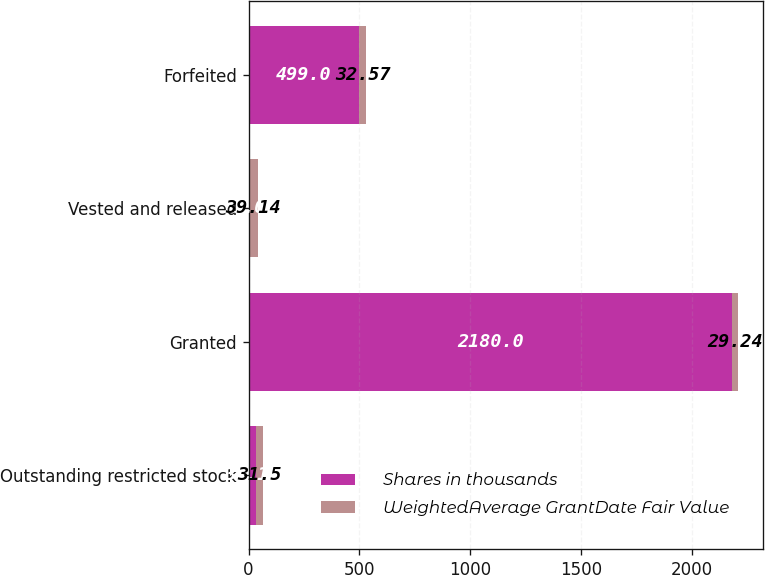Convert chart to OTSL. <chart><loc_0><loc_0><loc_500><loc_500><stacked_bar_chart><ecel><fcel>Outstanding restricted stock<fcel>Granted<fcel>Vested and released<fcel>Forfeited<nl><fcel>Shares in thousands<fcel>33.11<fcel>2180<fcel>3<fcel>499<nl><fcel>WeightedAverage GrantDate Fair Value<fcel>31.5<fcel>29.24<fcel>39.14<fcel>32.57<nl></chart> 